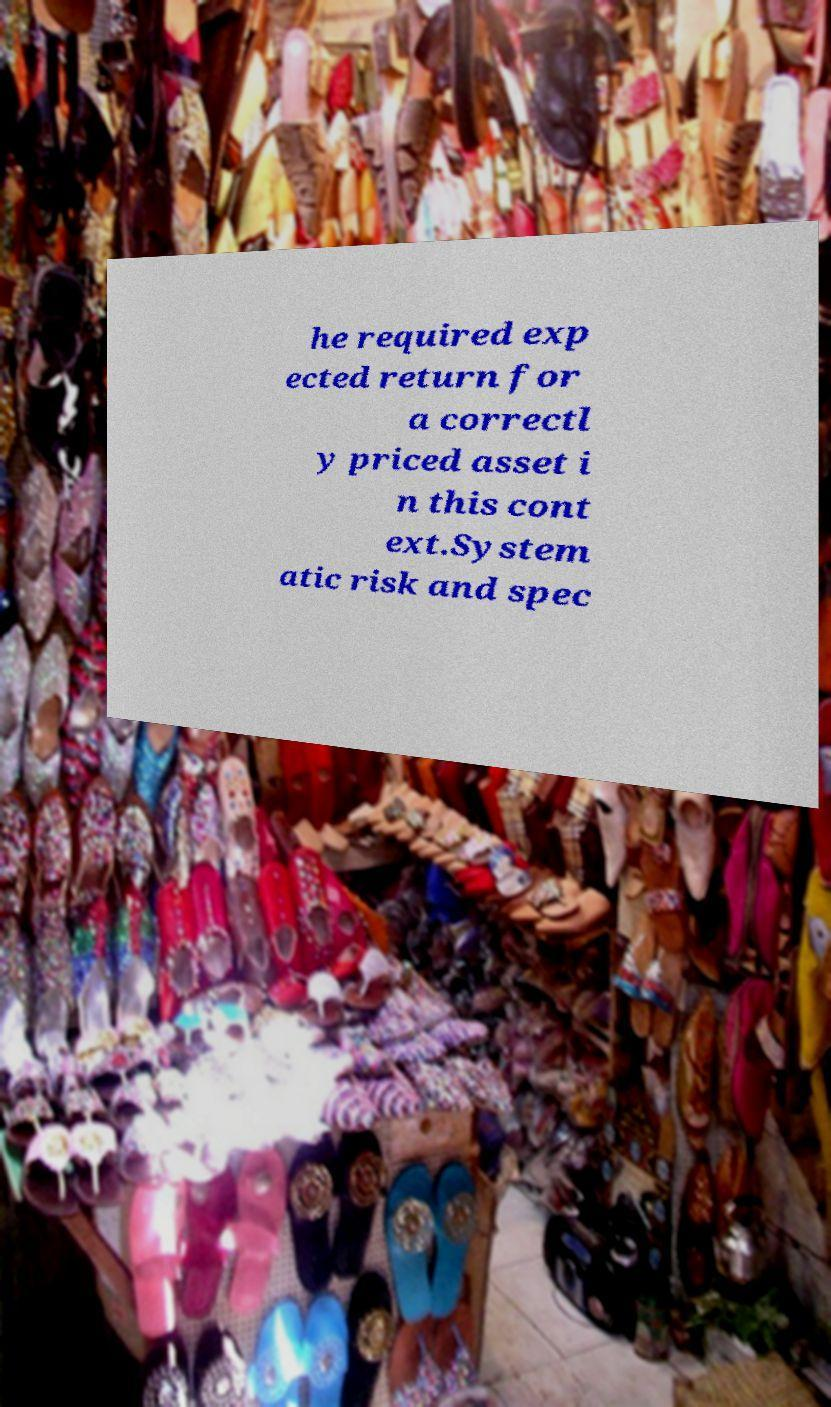There's text embedded in this image that I need extracted. Can you transcribe it verbatim? he required exp ected return for a correctl y priced asset i n this cont ext.System atic risk and spec 